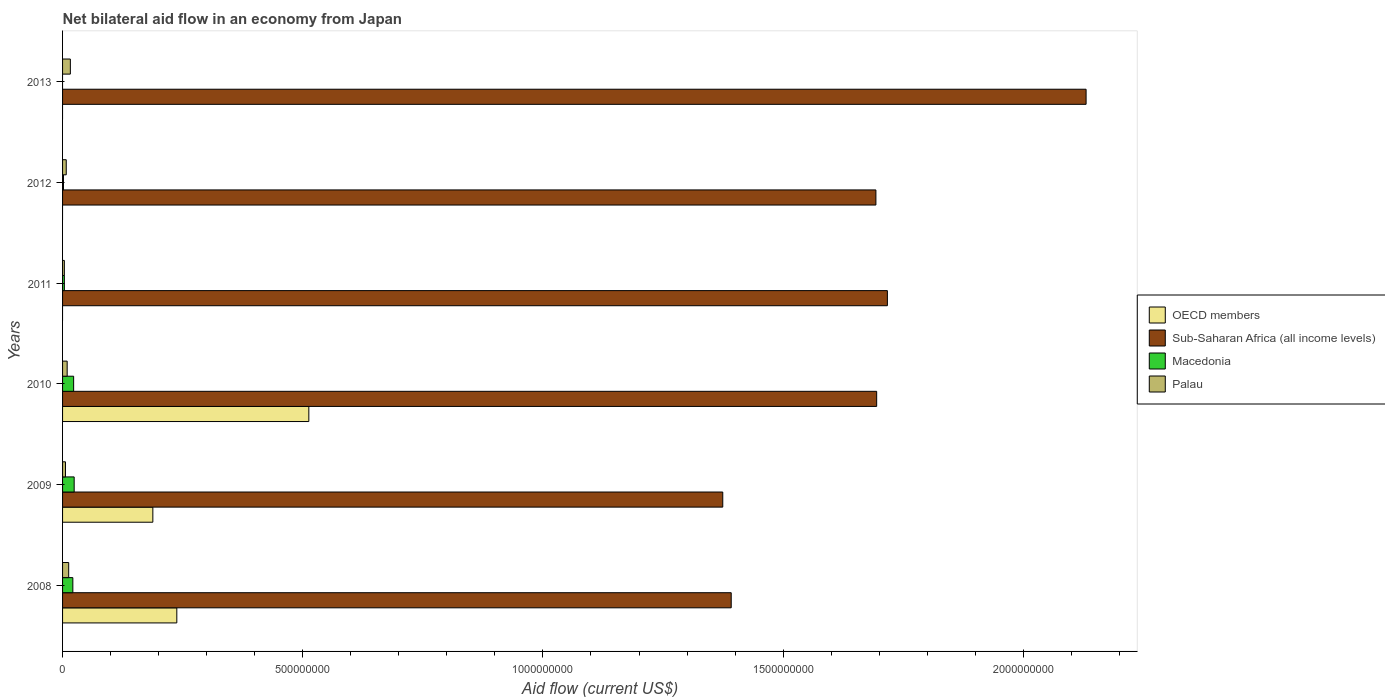How many different coloured bars are there?
Give a very brief answer. 4. Are the number of bars per tick equal to the number of legend labels?
Make the answer very short. No. Are the number of bars on each tick of the Y-axis equal?
Your answer should be compact. No. What is the label of the 2nd group of bars from the top?
Your answer should be very brief. 2012. What is the net bilateral aid flow in OECD members in 2010?
Give a very brief answer. 5.13e+08. Across all years, what is the maximum net bilateral aid flow in Macedonia?
Offer a terse response. 2.42e+07. Across all years, what is the minimum net bilateral aid flow in Macedonia?
Provide a succinct answer. 0. In which year was the net bilateral aid flow in Palau maximum?
Your response must be concise. 2013. What is the total net bilateral aid flow in Macedonia in the graph?
Keep it short and to the point. 7.42e+07. What is the difference between the net bilateral aid flow in OECD members in 2008 and that in 2009?
Ensure brevity in your answer.  4.99e+07. What is the difference between the net bilateral aid flow in Palau in 2009 and the net bilateral aid flow in OECD members in 2012?
Your response must be concise. 6.07e+06. What is the average net bilateral aid flow in Macedonia per year?
Your answer should be compact. 1.24e+07. In the year 2010, what is the difference between the net bilateral aid flow in Sub-Saharan Africa (all income levels) and net bilateral aid flow in OECD members?
Keep it short and to the point. 1.18e+09. In how many years, is the net bilateral aid flow in Sub-Saharan Africa (all income levels) greater than 700000000 US$?
Your answer should be compact. 6. What is the ratio of the net bilateral aid flow in Sub-Saharan Africa (all income levels) in 2009 to that in 2010?
Provide a succinct answer. 0.81. Is the net bilateral aid flow in Palau in 2008 less than that in 2012?
Your response must be concise. No. What is the difference between the highest and the second highest net bilateral aid flow in Macedonia?
Provide a short and direct response. 1.10e+06. What is the difference between the highest and the lowest net bilateral aid flow in Macedonia?
Offer a very short reply. 2.42e+07. In how many years, is the net bilateral aid flow in Palau greater than the average net bilateral aid flow in Palau taken over all years?
Offer a very short reply. 3. Is the sum of the net bilateral aid flow in Palau in 2011 and 2012 greater than the maximum net bilateral aid flow in Macedonia across all years?
Make the answer very short. No. How many bars are there?
Make the answer very short. 20. How many years are there in the graph?
Keep it short and to the point. 6. What is the difference between two consecutive major ticks on the X-axis?
Make the answer very short. 5.00e+08. Are the values on the major ticks of X-axis written in scientific E-notation?
Your response must be concise. No. Where does the legend appear in the graph?
Provide a short and direct response. Center right. How many legend labels are there?
Give a very brief answer. 4. How are the legend labels stacked?
Your answer should be very brief. Vertical. What is the title of the graph?
Offer a very short reply. Net bilateral aid flow in an economy from Japan. What is the Aid flow (current US$) in OECD members in 2008?
Your answer should be compact. 2.38e+08. What is the Aid flow (current US$) of Sub-Saharan Africa (all income levels) in 2008?
Give a very brief answer. 1.39e+09. What is the Aid flow (current US$) in Macedonia in 2008?
Offer a very short reply. 2.14e+07. What is the Aid flow (current US$) in Palau in 2008?
Ensure brevity in your answer.  1.27e+07. What is the Aid flow (current US$) in OECD members in 2009?
Offer a very short reply. 1.88e+08. What is the Aid flow (current US$) in Sub-Saharan Africa (all income levels) in 2009?
Offer a terse response. 1.37e+09. What is the Aid flow (current US$) in Macedonia in 2009?
Your response must be concise. 2.42e+07. What is the Aid flow (current US$) of Palau in 2009?
Make the answer very short. 6.07e+06. What is the Aid flow (current US$) in OECD members in 2010?
Provide a succinct answer. 5.13e+08. What is the Aid flow (current US$) of Sub-Saharan Africa (all income levels) in 2010?
Give a very brief answer. 1.69e+09. What is the Aid flow (current US$) of Macedonia in 2010?
Provide a succinct answer. 2.30e+07. What is the Aid flow (current US$) in Palau in 2010?
Give a very brief answer. 9.58e+06. What is the Aid flow (current US$) of Sub-Saharan Africa (all income levels) in 2011?
Provide a short and direct response. 1.72e+09. What is the Aid flow (current US$) in Macedonia in 2011?
Provide a short and direct response. 3.75e+06. What is the Aid flow (current US$) of Palau in 2011?
Offer a terse response. 3.73e+06. What is the Aid flow (current US$) of Sub-Saharan Africa (all income levels) in 2012?
Offer a very short reply. 1.69e+09. What is the Aid flow (current US$) of Macedonia in 2012?
Your answer should be very brief. 1.90e+06. What is the Aid flow (current US$) in Palau in 2012?
Ensure brevity in your answer.  7.68e+06. What is the Aid flow (current US$) of Sub-Saharan Africa (all income levels) in 2013?
Offer a very short reply. 2.13e+09. What is the Aid flow (current US$) in Macedonia in 2013?
Offer a very short reply. 0. What is the Aid flow (current US$) in Palau in 2013?
Your answer should be very brief. 1.62e+07. Across all years, what is the maximum Aid flow (current US$) in OECD members?
Your answer should be very brief. 5.13e+08. Across all years, what is the maximum Aid flow (current US$) of Sub-Saharan Africa (all income levels)?
Your answer should be compact. 2.13e+09. Across all years, what is the maximum Aid flow (current US$) of Macedonia?
Offer a very short reply. 2.42e+07. Across all years, what is the maximum Aid flow (current US$) in Palau?
Make the answer very short. 1.62e+07. Across all years, what is the minimum Aid flow (current US$) in Sub-Saharan Africa (all income levels)?
Keep it short and to the point. 1.37e+09. Across all years, what is the minimum Aid flow (current US$) of Macedonia?
Ensure brevity in your answer.  0. Across all years, what is the minimum Aid flow (current US$) of Palau?
Your answer should be compact. 3.73e+06. What is the total Aid flow (current US$) of OECD members in the graph?
Ensure brevity in your answer.  9.38e+08. What is the total Aid flow (current US$) of Sub-Saharan Africa (all income levels) in the graph?
Your response must be concise. 1.00e+1. What is the total Aid flow (current US$) in Macedonia in the graph?
Your answer should be compact. 7.42e+07. What is the total Aid flow (current US$) in Palau in the graph?
Make the answer very short. 5.60e+07. What is the difference between the Aid flow (current US$) in OECD members in 2008 and that in 2009?
Provide a succinct answer. 4.99e+07. What is the difference between the Aid flow (current US$) in Sub-Saharan Africa (all income levels) in 2008 and that in 2009?
Your answer should be very brief. 1.76e+07. What is the difference between the Aid flow (current US$) in Macedonia in 2008 and that in 2009?
Your answer should be very brief. -2.76e+06. What is the difference between the Aid flow (current US$) of Palau in 2008 and that in 2009?
Keep it short and to the point. 6.66e+06. What is the difference between the Aid flow (current US$) in OECD members in 2008 and that in 2010?
Ensure brevity in your answer.  -2.75e+08. What is the difference between the Aid flow (current US$) of Sub-Saharan Africa (all income levels) in 2008 and that in 2010?
Keep it short and to the point. -3.03e+08. What is the difference between the Aid flow (current US$) in Macedonia in 2008 and that in 2010?
Make the answer very short. -1.66e+06. What is the difference between the Aid flow (current US$) of Palau in 2008 and that in 2010?
Ensure brevity in your answer.  3.15e+06. What is the difference between the Aid flow (current US$) in Sub-Saharan Africa (all income levels) in 2008 and that in 2011?
Keep it short and to the point. -3.25e+08. What is the difference between the Aid flow (current US$) of Macedonia in 2008 and that in 2011?
Your answer should be very brief. 1.76e+07. What is the difference between the Aid flow (current US$) in Palau in 2008 and that in 2011?
Provide a succinct answer. 9.00e+06. What is the difference between the Aid flow (current US$) of Sub-Saharan Africa (all income levels) in 2008 and that in 2012?
Make the answer very short. -3.01e+08. What is the difference between the Aid flow (current US$) in Macedonia in 2008 and that in 2012?
Make the answer very short. 1.95e+07. What is the difference between the Aid flow (current US$) in Palau in 2008 and that in 2012?
Offer a very short reply. 5.05e+06. What is the difference between the Aid flow (current US$) of Sub-Saharan Africa (all income levels) in 2008 and that in 2013?
Ensure brevity in your answer.  -7.39e+08. What is the difference between the Aid flow (current US$) of Palau in 2008 and that in 2013?
Give a very brief answer. -3.48e+06. What is the difference between the Aid flow (current US$) in OECD members in 2009 and that in 2010?
Your answer should be compact. -3.25e+08. What is the difference between the Aid flow (current US$) in Sub-Saharan Africa (all income levels) in 2009 and that in 2010?
Ensure brevity in your answer.  -3.20e+08. What is the difference between the Aid flow (current US$) in Macedonia in 2009 and that in 2010?
Offer a very short reply. 1.10e+06. What is the difference between the Aid flow (current US$) of Palau in 2009 and that in 2010?
Provide a short and direct response. -3.51e+06. What is the difference between the Aid flow (current US$) in Sub-Saharan Africa (all income levels) in 2009 and that in 2011?
Your answer should be very brief. -3.43e+08. What is the difference between the Aid flow (current US$) in Macedonia in 2009 and that in 2011?
Keep it short and to the point. 2.04e+07. What is the difference between the Aid flow (current US$) of Palau in 2009 and that in 2011?
Offer a terse response. 2.34e+06. What is the difference between the Aid flow (current US$) of Sub-Saharan Africa (all income levels) in 2009 and that in 2012?
Provide a short and direct response. -3.19e+08. What is the difference between the Aid flow (current US$) of Macedonia in 2009 and that in 2012?
Make the answer very short. 2.22e+07. What is the difference between the Aid flow (current US$) in Palau in 2009 and that in 2012?
Your response must be concise. -1.61e+06. What is the difference between the Aid flow (current US$) in Sub-Saharan Africa (all income levels) in 2009 and that in 2013?
Your response must be concise. -7.56e+08. What is the difference between the Aid flow (current US$) in Palau in 2009 and that in 2013?
Offer a very short reply. -1.01e+07. What is the difference between the Aid flow (current US$) in Sub-Saharan Africa (all income levels) in 2010 and that in 2011?
Your response must be concise. -2.23e+07. What is the difference between the Aid flow (current US$) in Macedonia in 2010 and that in 2011?
Give a very brief answer. 1.93e+07. What is the difference between the Aid flow (current US$) in Palau in 2010 and that in 2011?
Your answer should be very brief. 5.85e+06. What is the difference between the Aid flow (current US$) in Sub-Saharan Africa (all income levels) in 2010 and that in 2012?
Your response must be concise. 1.62e+06. What is the difference between the Aid flow (current US$) in Macedonia in 2010 and that in 2012?
Your answer should be very brief. 2.12e+07. What is the difference between the Aid flow (current US$) of Palau in 2010 and that in 2012?
Offer a terse response. 1.90e+06. What is the difference between the Aid flow (current US$) of Sub-Saharan Africa (all income levels) in 2010 and that in 2013?
Ensure brevity in your answer.  -4.36e+08. What is the difference between the Aid flow (current US$) in Palau in 2010 and that in 2013?
Offer a terse response. -6.63e+06. What is the difference between the Aid flow (current US$) of Sub-Saharan Africa (all income levels) in 2011 and that in 2012?
Keep it short and to the point. 2.39e+07. What is the difference between the Aid flow (current US$) in Macedonia in 2011 and that in 2012?
Offer a very short reply. 1.85e+06. What is the difference between the Aid flow (current US$) in Palau in 2011 and that in 2012?
Your answer should be very brief. -3.95e+06. What is the difference between the Aid flow (current US$) of Sub-Saharan Africa (all income levels) in 2011 and that in 2013?
Make the answer very short. -4.14e+08. What is the difference between the Aid flow (current US$) of Palau in 2011 and that in 2013?
Your response must be concise. -1.25e+07. What is the difference between the Aid flow (current US$) of Sub-Saharan Africa (all income levels) in 2012 and that in 2013?
Keep it short and to the point. -4.38e+08. What is the difference between the Aid flow (current US$) in Palau in 2012 and that in 2013?
Provide a succinct answer. -8.53e+06. What is the difference between the Aid flow (current US$) in OECD members in 2008 and the Aid flow (current US$) in Sub-Saharan Africa (all income levels) in 2009?
Provide a short and direct response. -1.14e+09. What is the difference between the Aid flow (current US$) in OECD members in 2008 and the Aid flow (current US$) in Macedonia in 2009?
Your answer should be compact. 2.14e+08. What is the difference between the Aid flow (current US$) of OECD members in 2008 and the Aid flow (current US$) of Palau in 2009?
Ensure brevity in your answer.  2.32e+08. What is the difference between the Aid flow (current US$) in Sub-Saharan Africa (all income levels) in 2008 and the Aid flow (current US$) in Macedonia in 2009?
Your answer should be very brief. 1.37e+09. What is the difference between the Aid flow (current US$) of Sub-Saharan Africa (all income levels) in 2008 and the Aid flow (current US$) of Palau in 2009?
Offer a very short reply. 1.39e+09. What is the difference between the Aid flow (current US$) in Macedonia in 2008 and the Aid flow (current US$) in Palau in 2009?
Your answer should be compact. 1.53e+07. What is the difference between the Aid flow (current US$) in OECD members in 2008 and the Aid flow (current US$) in Sub-Saharan Africa (all income levels) in 2010?
Give a very brief answer. -1.46e+09. What is the difference between the Aid flow (current US$) of OECD members in 2008 and the Aid flow (current US$) of Macedonia in 2010?
Make the answer very short. 2.15e+08. What is the difference between the Aid flow (current US$) of OECD members in 2008 and the Aid flow (current US$) of Palau in 2010?
Provide a short and direct response. 2.28e+08. What is the difference between the Aid flow (current US$) in Sub-Saharan Africa (all income levels) in 2008 and the Aid flow (current US$) in Macedonia in 2010?
Keep it short and to the point. 1.37e+09. What is the difference between the Aid flow (current US$) in Sub-Saharan Africa (all income levels) in 2008 and the Aid flow (current US$) in Palau in 2010?
Offer a very short reply. 1.38e+09. What is the difference between the Aid flow (current US$) of Macedonia in 2008 and the Aid flow (current US$) of Palau in 2010?
Your response must be concise. 1.18e+07. What is the difference between the Aid flow (current US$) of OECD members in 2008 and the Aid flow (current US$) of Sub-Saharan Africa (all income levels) in 2011?
Make the answer very short. -1.48e+09. What is the difference between the Aid flow (current US$) of OECD members in 2008 and the Aid flow (current US$) of Macedonia in 2011?
Provide a short and direct response. 2.34e+08. What is the difference between the Aid flow (current US$) of OECD members in 2008 and the Aid flow (current US$) of Palau in 2011?
Offer a terse response. 2.34e+08. What is the difference between the Aid flow (current US$) of Sub-Saharan Africa (all income levels) in 2008 and the Aid flow (current US$) of Macedonia in 2011?
Your answer should be compact. 1.39e+09. What is the difference between the Aid flow (current US$) in Sub-Saharan Africa (all income levels) in 2008 and the Aid flow (current US$) in Palau in 2011?
Offer a terse response. 1.39e+09. What is the difference between the Aid flow (current US$) of Macedonia in 2008 and the Aid flow (current US$) of Palau in 2011?
Your answer should be compact. 1.77e+07. What is the difference between the Aid flow (current US$) in OECD members in 2008 and the Aid flow (current US$) in Sub-Saharan Africa (all income levels) in 2012?
Your answer should be very brief. -1.46e+09. What is the difference between the Aid flow (current US$) in OECD members in 2008 and the Aid flow (current US$) in Macedonia in 2012?
Your answer should be very brief. 2.36e+08. What is the difference between the Aid flow (current US$) of OECD members in 2008 and the Aid flow (current US$) of Palau in 2012?
Provide a short and direct response. 2.30e+08. What is the difference between the Aid flow (current US$) in Sub-Saharan Africa (all income levels) in 2008 and the Aid flow (current US$) in Macedonia in 2012?
Your answer should be compact. 1.39e+09. What is the difference between the Aid flow (current US$) of Sub-Saharan Africa (all income levels) in 2008 and the Aid flow (current US$) of Palau in 2012?
Provide a short and direct response. 1.38e+09. What is the difference between the Aid flow (current US$) of Macedonia in 2008 and the Aid flow (current US$) of Palau in 2012?
Your answer should be compact. 1.37e+07. What is the difference between the Aid flow (current US$) in OECD members in 2008 and the Aid flow (current US$) in Sub-Saharan Africa (all income levels) in 2013?
Provide a succinct answer. -1.89e+09. What is the difference between the Aid flow (current US$) of OECD members in 2008 and the Aid flow (current US$) of Palau in 2013?
Provide a short and direct response. 2.22e+08. What is the difference between the Aid flow (current US$) in Sub-Saharan Africa (all income levels) in 2008 and the Aid flow (current US$) in Palau in 2013?
Your answer should be compact. 1.38e+09. What is the difference between the Aid flow (current US$) in Macedonia in 2008 and the Aid flow (current US$) in Palau in 2013?
Your answer should be very brief. 5.18e+06. What is the difference between the Aid flow (current US$) in OECD members in 2009 and the Aid flow (current US$) in Sub-Saharan Africa (all income levels) in 2010?
Your answer should be compact. -1.51e+09. What is the difference between the Aid flow (current US$) in OECD members in 2009 and the Aid flow (current US$) in Macedonia in 2010?
Provide a short and direct response. 1.65e+08. What is the difference between the Aid flow (current US$) in OECD members in 2009 and the Aid flow (current US$) in Palau in 2010?
Ensure brevity in your answer.  1.78e+08. What is the difference between the Aid flow (current US$) of Sub-Saharan Africa (all income levels) in 2009 and the Aid flow (current US$) of Macedonia in 2010?
Give a very brief answer. 1.35e+09. What is the difference between the Aid flow (current US$) in Sub-Saharan Africa (all income levels) in 2009 and the Aid flow (current US$) in Palau in 2010?
Give a very brief answer. 1.36e+09. What is the difference between the Aid flow (current US$) in Macedonia in 2009 and the Aid flow (current US$) in Palau in 2010?
Provide a short and direct response. 1.46e+07. What is the difference between the Aid flow (current US$) in OECD members in 2009 and the Aid flow (current US$) in Sub-Saharan Africa (all income levels) in 2011?
Provide a short and direct response. -1.53e+09. What is the difference between the Aid flow (current US$) in OECD members in 2009 and the Aid flow (current US$) in Macedonia in 2011?
Provide a succinct answer. 1.84e+08. What is the difference between the Aid flow (current US$) of OECD members in 2009 and the Aid flow (current US$) of Palau in 2011?
Ensure brevity in your answer.  1.84e+08. What is the difference between the Aid flow (current US$) in Sub-Saharan Africa (all income levels) in 2009 and the Aid flow (current US$) in Macedonia in 2011?
Make the answer very short. 1.37e+09. What is the difference between the Aid flow (current US$) in Sub-Saharan Africa (all income levels) in 2009 and the Aid flow (current US$) in Palau in 2011?
Offer a very short reply. 1.37e+09. What is the difference between the Aid flow (current US$) in Macedonia in 2009 and the Aid flow (current US$) in Palau in 2011?
Keep it short and to the point. 2.04e+07. What is the difference between the Aid flow (current US$) of OECD members in 2009 and the Aid flow (current US$) of Sub-Saharan Africa (all income levels) in 2012?
Make the answer very short. -1.51e+09. What is the difference between the Aid flow (current US$) in OECD members in 2009 and the Aid flow (current US$) in Macedonia in 2012?
Make the answer very short. 1.86e+08. What is the difference between the Aid flow (current US$) in OECD members in 2009 and the Aid flow (current US$) in Palau in 2012?
Offer a terse response. 1.80e+08. What is the difference between the Aid flow (current US$) in Sub-Saharan Africa (all income levels) in 2009 and the Aid flow (current US$) in Macedonia in 2012?
Your response must be concise. 1.37e+09. What is the difference between the Aid flow (current US$) in Sub-Saharan Africa (all income levels) in 2009 and the Aid flow (current US$) in Palau in 2012?
Give a very brief answer. 1.37e+09. What is the difference between the Aid flow (current US$) of Macedonia in 2009 and the Aid flow (current US$) of Palau in 2012?
Provide a short and direct response. 1.65e+07. What is the difference between the Aid flow (current US$) of OECD members in 2009 and the Aid flow (current US$) of Sub-Saharan Africa (all income levels) in 2013?
Give a very brief answer. -1.94e+09. What is the difference between the Aid flow (current US$) in OECD members in 2009 and the Aid flow (current US$) in Palau in 2013?
Your answer should be compact. 1.72e+08. What is the difference between the Aid flow (current US$) in Sub-Saharan Africa (all income levels) in 2009 and the Aid flow (current US$) in Palau in 2013?
Keep it short and to the point. 1.36e+09. What is the difference between the Aid flow (current US$) in Macedonia in 2009 and the Aid flow (current US$) in Palau in 2013?
Keep it short and to the point. 7.94e+06. What is the difference between the Aid flow (current US$) in OECD members in 2010 and the Aid flow (current US$) in Sub-Saharan Africa (all income levels) in 2011?
Your answer should be very brief. -1.20e+09. What is the difference between the Aid flow (current US$) of OECD members in 2010 and the Aid flow (current US$) of Macedonia in 2011?
Make the answer very short. 5.09e+08. What is the difference between the Aid flow (current US$) of OECD members in 2010 and the Aid flow (current US$) of Palau in 2011?
Provide a succinct answer. 5.09e+08. What is the difference between the Aid flow (current US$) in Sub-Saharan Africa (all income levels) in 2010 and the Aid flow (current US$) in Macedonia in 2011?
Offer a very short reply. 1.69e+09. What is the difference between the Aid flow (current US$) in Sub-Saharan Africa (all income levels) in 2010 and the Aid flow (current US$) in Palau in 2011?
Provide a succinct answer. 1.69e+09. What is the difference between the Aid flow (current US$) of Macedonia in 2010 and the Aid flow (current US$) of Palau in 2011?
Provide a short and direct response. 1.93e+07. What is the difference between the Aid flow (current US$) in OECD members in 2010 and the Aid flow (current US$) in Sub-Saharan Africa (all income levels) in 2012?
Provide a succinct answer. -1.18e+09. What is the difference between the Aid flow (current US$) of OECD members in 2010 and the Aid flow (current US$) of Macedonia in 2012?
Offer a very short reply. 5.11e+08. What is the difference between the Aid flow (current US$) of OECD members in 2010 and the Aid flow (current US$) of Palau in 2012?
Make the answer very short. 5.05e+08. What is the difference between the Aid flow (current US$) of Sub-Saharan Africa (all income levels) in 2010 and the Aid flow (current US$) of Macedonia in 2012?
Provide a short and direct response. 1.69e+09. What is the difference between the Aid flow (current US$) in Sub-Saharan Africa (all income levels) in 2010 and the Aid flow (current US$) in Palau in 2012?
Ensure brevity in your answer.  1.69e+09. What is the difference between the Aid flow (current US$) of Macedonia in 2010 and the Aid flow (current US$) of Palau in 2012?
Keep it short and to the point. 1.54e+07. What is the difference between the Aid flow (current US$) in OECD members in 2010 and the Aid flow (current US$) in Sub-Saharan Africa (all income levels) in 2013?
Offer a very short reply. -1.62e+09. What is the difference between the Aid flow (current US$) of OECD members in 2010 and the Aid flow (current US$) of Palau in 2013?
Your response must be concise. 4.96e+08. What is the difference between the Aid flow (current US$) of Sub-Saharan Africa (all income levels) in 2010 and the Aid flow (current US$) of Palau in 2013?
Keep it short and to the point. 1.68e+09. What is the difference between the Aid flow (current US$) in Macedonia in 2010 and the Aid flow (current US$) in Palau in 2013?
Ensure brevity in your answer.  6.84e+06. What is the difference between the Aid flow (current US$) of Sub-Saharan Africa (all income levels) in 2011 and the Aid flow (current US$) of Macedonia in 2012?
Your answer should be very brief. 1.72e+09. What is the difference between the Aid flow (current US$) in Sub-Saharan Africa (all income levels) in 2011 and the Aid flow (current US$) in Palau in 2012?
Provide a succinct answer. 1.71e+09. What is the difference between the Aid flow (current US$) of Macedonia in 2011 and the Aid flow (current US$) of Palau in 2012?
Make the answer very short. -3.93e+06. What is the difference between the Aid flow (current US$) of Sub-Saharan Africa (all income levels) in 2011 and the Aid flow (current US$) of Palau in 2013?
Provide a succinct answer. 1.70e+09. What is the difference between the Aid flow (current US$) of Macedonia in 2011 and the Aid flow (current US$) of Palau in 2013?
Offer a very short reply. -1.25e+07. What is the difference between the Aid flow (current US$) in Sub-Saharan Africa (all income levels) in 2012 and the Aid flow (current US$) in Palau in 2013?
Provide a short and direct response. 1.68e+09. What is the difference between the Aid flow (current US$) of Macedonia in 2012 and the Aid flow (current US$) of Palau in 2013?
Make the answer very short. -1.43e+07. What is the average Aid flow (current US$) in OECD members per year?
Provide a succinct answer. 1.56e+08. What is the average Aid flow (current US$) in Sub-Saharan Africa (all income levels) per year?
Keep it short and to the point. 1.67e+09. What is the average Aid flow (current US$) in Macedonia per year?
Your answer should be very brief. 1.24e+07. What is the average Aid flow (current US$) of Palau per year?
Make the answer very short. 9.33e+06. In the year 2008, what is the difference between the Aid flow (current US$) in OECD members and Aid flow (current US$) in Sub-Saharan Africa (all income levels)?
Provide a succinct answer. -1.15e+09. In the year 2008, what is the difference between the Aid flow (current US$) in OECD members and Aid flow (current US$) in Macedonia?
Provide a succinct answer. 2.16e+08. In the year 2008, what is the difference between the Aid flow (current US$) in OECD members and Aid flow (current US$) in Palau?
Provide a succinct answer. 2.25e+08. In the year 2008, what is the difference between the Aid flow (current US$) in Sub-Saharan Africa (all income levels) and Aid flow (current US$) in Macedonia?
Make the answer very short. 1.37e+09. In the year 2008, what is the difference between the Aid flow (current US$) of Sub-Saharan Africa (all income levels) and Aid flow (current US$) of Palau?
Your answer should be compact. 1.38e+09. In the year 2008, what is the difference between the Aid flow (current US$) in Macedonia and Aid flow (current US$) in Palau?
Provide a succinct answer. 8.66e+06. In the year 2009, what is the difference between the Aid flow (current US$) in OECD members and Aid flow (current US$) in Sub-Saharan Africa (all income levels)?
Keep it short and to the point. -1.19e+09. In the year 2009, what is the difference between the Aid flow (current US$) in OECD members and Aid flow (current US$) in Macedonia?
Give a very brief answer. 1.64e+08. In the year 2009, what is the difference between the Aid flow (current US$) in OECD members and Aid flow (current US$) in Palau?
Ensure brevity in your answer.  1.82e+08. In the year 2009, what is the difference between the Aid flow (current US$) of Sub-Saharan Africa (all income levels) and Aid flow (current US$) of Macedonia?
Offer a terse response. 1.35e+09. In the year 2009, what is the difference between the Aid flow (current US$) of Sub-Saharan Africa (all income levels) and Aid flow (current US$) of Palau?
Ensure brevity in your answer.  1.37e+09. In the year 2009, what is the difference between the Aid flow (current US$) of Macedonia and Aid flow (current US$) of Palau?
Ensure brevity in your answer.  1.81e+07. In the year 2010, what is the difference between the Aid flow (current US$) in OECD members and Aid flow (current US$) in Sub-Saharan Africa (all income levels)?
Make the answer very short. -1.18e+09. In the year 2010, what is the difference between the Aid flow (current US$) in OECD members and Aid flow (current US$) in Macedonia?
Provide a succinct answer. 4.90e+08. In the year 2010, what is the difference between the Aid flow (current US$) of OECD members and Aid flow (current US$) of Palau?
Make the answer very short. 5.03e+08. In the year 2010, what is the difference between the Aid flow (current US$) of Sub-Saharan Africa (all income levels) and Aid flow (current US$) of Macedonia?
Make the answer very short. 1.67e+09. In the year 2010, what is the difference between the Aid flow (current US$) in Sub-Saharan Africa (all income levels) and Aid flow (current US$) in Palau?
Offer a very short reply. 1.69e+09. In the year 2010, what is the difference between the Aid flow (current US$) of Macedonia and Aid flow (current US$) of Palau?
Your answer should be very brief. 1.35e+07. In the year 2011, what is the difference between the Aid flow (current US$) in Sub-Saharan Africa (all income levels) and Aid flow (current US$) in Macedonia?
Offer a very short reply. 1.71e+09. In the year 2011, what is the difference between the Aid flow (current US$) in Sub-Saharan Africa (all income levels) and Aid flow (current US$) in Palau?
Offer a terse response. 1.71e+09. In the year 2012, what is the difference between the Aid flow (current US$) in Sub-Saharan Africa (all income levels) and Aid flow (current US$) in Macedonia?
Offer a terse response. 1.69e+09. In the year 2012, what is the difference between the Aid flow (current US$) of Sub-Saharan Africa (all income levels) and Aid flow (current US$) of Palau?
Make the answer very short. 1.69e+09. In the year 2012, what is the difference between the Aid flow (current US$) of Macedonia and Aid flow (current US$) of Palau?
Make the answer very short. -5.78e+06. In the year 2013, what is the difference between the Aid flow (current US$) of Sub-Saharan Africa (all income levels) and Aid flow (current US$) of Palau?
Your answer should be very brief. 2.11e+09. What is the ratio of the Aid flow (current US$) of OECD members in 2008 to that in 2009?
Give a very brief answer. 1.27. What is the ratio of the Aid flow (current US$) of Sub-Saharan Africa (all income levels) in 2008 to that in 2009?
Your response must be concise. 1.01. What is the ratio of the Aid flow (current US$) in Macedonia in 2008 to that in 2009?
Your answer should be compact. 0.89. What is the ratio of the Aid flow (current US$) of Palau in 2008 to that in 2009?
Ensure brevity in your answer.  2.1. What is the ratio of the Aid flow (current US$) in OECD members in 2008 to that in 2010?
Your answer should be very brief. 0.46. What is the ratio of the Aid flow (current US$) of Sub-Saharan Africa (all income levels) in 2008 to that in 2010?
Provide a short and direct response. 0.82. What is the ratio of the Aid flow (current US$) in Macedonia in 2008 to that in 2010?
Make the answer very short. 0.93. What is the ratio of the Aid flow (current US$) of Palau in 2008 to that in 2010?
Your response must be concise. 1.33. What is the ratio of the Aid flow (current US$) in Sub-Saharan Africa (all income levels) in 2008 to that in 2011?
Provide a succinct answer. 0.81. What is the ratio of the Aid flow (current US$) of Macedonia in 2008 to that in 2011?
Make the answer very short. 5.7. What is the ratio of the Aid flow (current US$) of Palau in 2008 to that in 2011?
Provide a succinct answer. 3.41. What is the ratio of the Aid flow (current US$) in Sub-Saharan Africa (all income levels) in 2008 to that in 2012?
Offer a very short reply. 0.82. What is the ratio of the Aid flow (current US$) in Macedonia in 2008 to that in 2012?
Give a very brief answer. 11.26. What is the ratio of the Aid flow (current US$) in Palau in 2008 to that in 2012?
Provide a succinct answer. 1.66. What is the ratio of the Aid flow (current US$) of Sub-Saharan Africa (all income levels) in 2008 to that in 2013?
Keep it short and to the point. 0.65. What is the ratio of the Aid flow (current US$) of Palau in 2008 to that in 2013?
Offer a very short reply. 0.79. What is the ratio of the Aid flow (current US$) in OECD members in 2009 to that in 2010?
Make the answer very short. 0.37. What is the ratio of the Aid flow (current US$) in Sub-Saharan Africa (all income levels) in 2009 to that in 2010?
Offer a very short reply. 0.81. What is the ratio of the Aid flow (current US$) in Macedonia in 2009 to that in 2010?
Keep it short and to the point. 1.05. What is the ratio of the Aid flow (current US$) in Palau in 2009 to that in 2010?
Your answer should be compact. 0.63. What is the ratio of the Aid flow (current US$) of Sub-Saharan Africa (all income levels) in 2009 to that in 2011?
Offer a terse response. 0.8. What is the ratio of the Aid flow (current US$) of Macedonia in 2009 to that in 2011?
Your response must be concise. 6.44. What is the ratio of the Aid flow (current US$) in Palau in 2009 to that in 2011?
Offer a terse response. 1.63. What is the ratio of the Aid flow (current US$) of Sub-Saharan Africa (all income levels) in 2009 to that in 2012?
Offer a very short reply. 0.81. What is the ratio of the Aid flow (current US$) of Macedonia in 2009 to that in 2012?
Provide a short and direct response. 12.71. What is the ratio of the Aid flow (current US$) of Palau in 2009 to that in 2012?
Provide a succinct answer. 0.79. What is the ratio of the Aid flow (current US$) in Sub-Saharan Africa (all income levels) in 2009 to that in 2013?
Give a very brief answer. 0.65. What is the ratio of the Aid flow (current US$) in Palau in 2009 to that in 2013?
Make the answer very short. 0.37. What is the ratio of the Aid flow (current US$) in Sub-Saharan Africa (all income levels) in 2010 to that in 2011?
Provide a short and direct response. 0.99. What is the ratio of the Aid flow (current US$) in Macedonia in 2010 to that in 2011?
Your answer should be very brief. 6.15. What is the ratio of the Aid flow (current US$) in Palau in 2010 to that in 2011?
Give a very brief answer. 2.57. What is the ratio of the Aid flow (current US$) in Sub-Saharan Africa (all income levels) in 2010 to that in 2012?
Provide a succinct answer. 1. What is the ratio of the Aid flow (current US$) in Macedonia in 2010 to that in 2012?
Give a very brief answer. 12.13. What is the ratio of the Aid flow (current US$) in Palau in 2010 to that in 2012?
Ensure brevity in your answer.  1.25. What is the ratio of the Aid flow (current US$) of Sub-Saharan Africa (all income levels) in 2010 to that in 2013?
Your answer should be very brief. 0.8. What is the ratio of the Aid flow (current US$) in Palau in 2010 to that in 2013?
Ensure brevity in your answer.  0.59. What is the ratio of the Aid flow (current US$) of Sub-Saharan Africa (all income levels) in 2011 to that in 2012?
Provide a succinct answer. 1.01. What is the ratio of the Aid flow (current US$) of Macedonia in 2011 to that in 2012?
Provide a succinct answer. 1.97. What is the ratio of the Aid flow (current US$) of Palau in 2011 to that in 2012?
Offer a terse response. 0.49. What is the ratio of the Aid flow (current US$) in Sub-Saharan Africa (all income levels) in 2011 to that in 2013?
Give a very brief answer. 0.81. What is the ratio of the Aid flow (current US$) of Palau in 2011 to that in 2013?
Make the answer very short. 0.23. What is the ratio of the Aid flow (current US$) of Sub-Saharan Africa (all income levels) in 2012 to that in 2013?
Give a very brief answer. 0.79. What is the ratio of the Aid flow (current US$) of Palau in 2012 to that in 2013?
Your answer should be very brief. 0.47. What is the difference between the highest and the second highest Aid flow (current US$) in OECD members?
Your response must be concise. 2.75e+08. What is the difference between the highest and the second highest Aid flow (current US$) in Sub-Saharan Africa (all income levels)?
Your answer should be compact. 4.14e+08. What is the difference between the highest and the second highest Aid flow (current US$) of Macedonia?
Provide a short and direct response. 1.10e+06. What is the difference between the highest and the second highest Aid flow (current US$) of Palau?
Ensure brevity in your answer.  3.48e+06. What is the difference between the highest and the lowest Aid flow (current US$) in OECD members?
Provide a succinct answer. 5.13e+08. What is the difference between the highest and the lowest Aid flow (current US$) of Sub-Saharan Africa (all income levels)?
Make the answer very short. 7.56e+08. What is the difference between the highest and the lowest Aid flow (current US$) in Macedonia?
Offer a very short reply. 2.42e+07. What is the difference between the highest and the lowest Aid flow (current US$) of Palau?
Offer a terse response. 1.25e+07. 